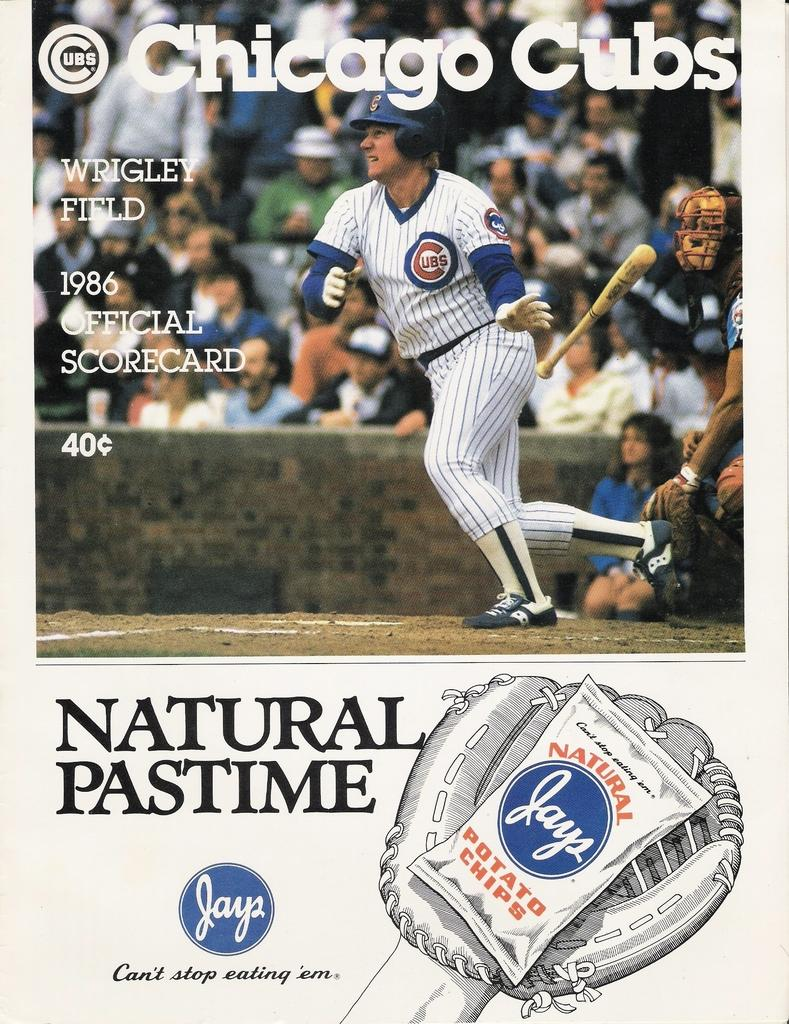<image>
Provide a brief description of the given image. Chicago cubs magazine with nature pastime chips at the bottom 